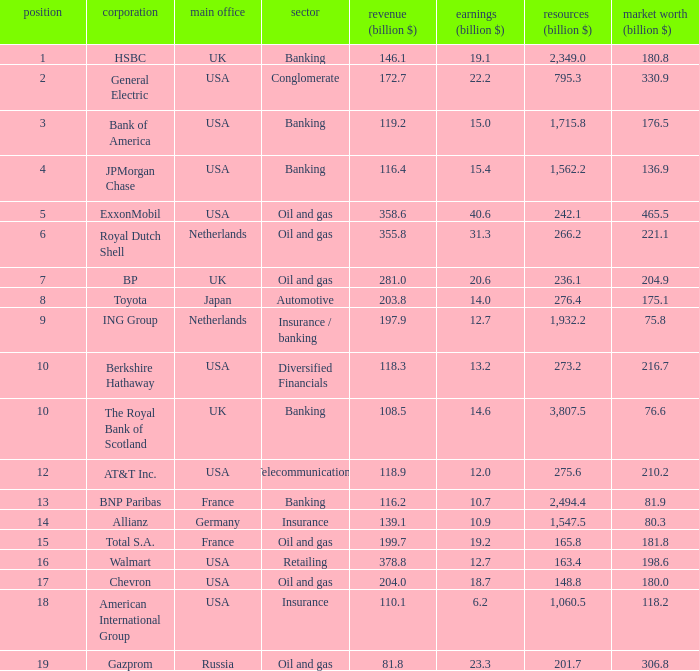Which industry has a company with a market value of 80.3 billion?  Insurance. 